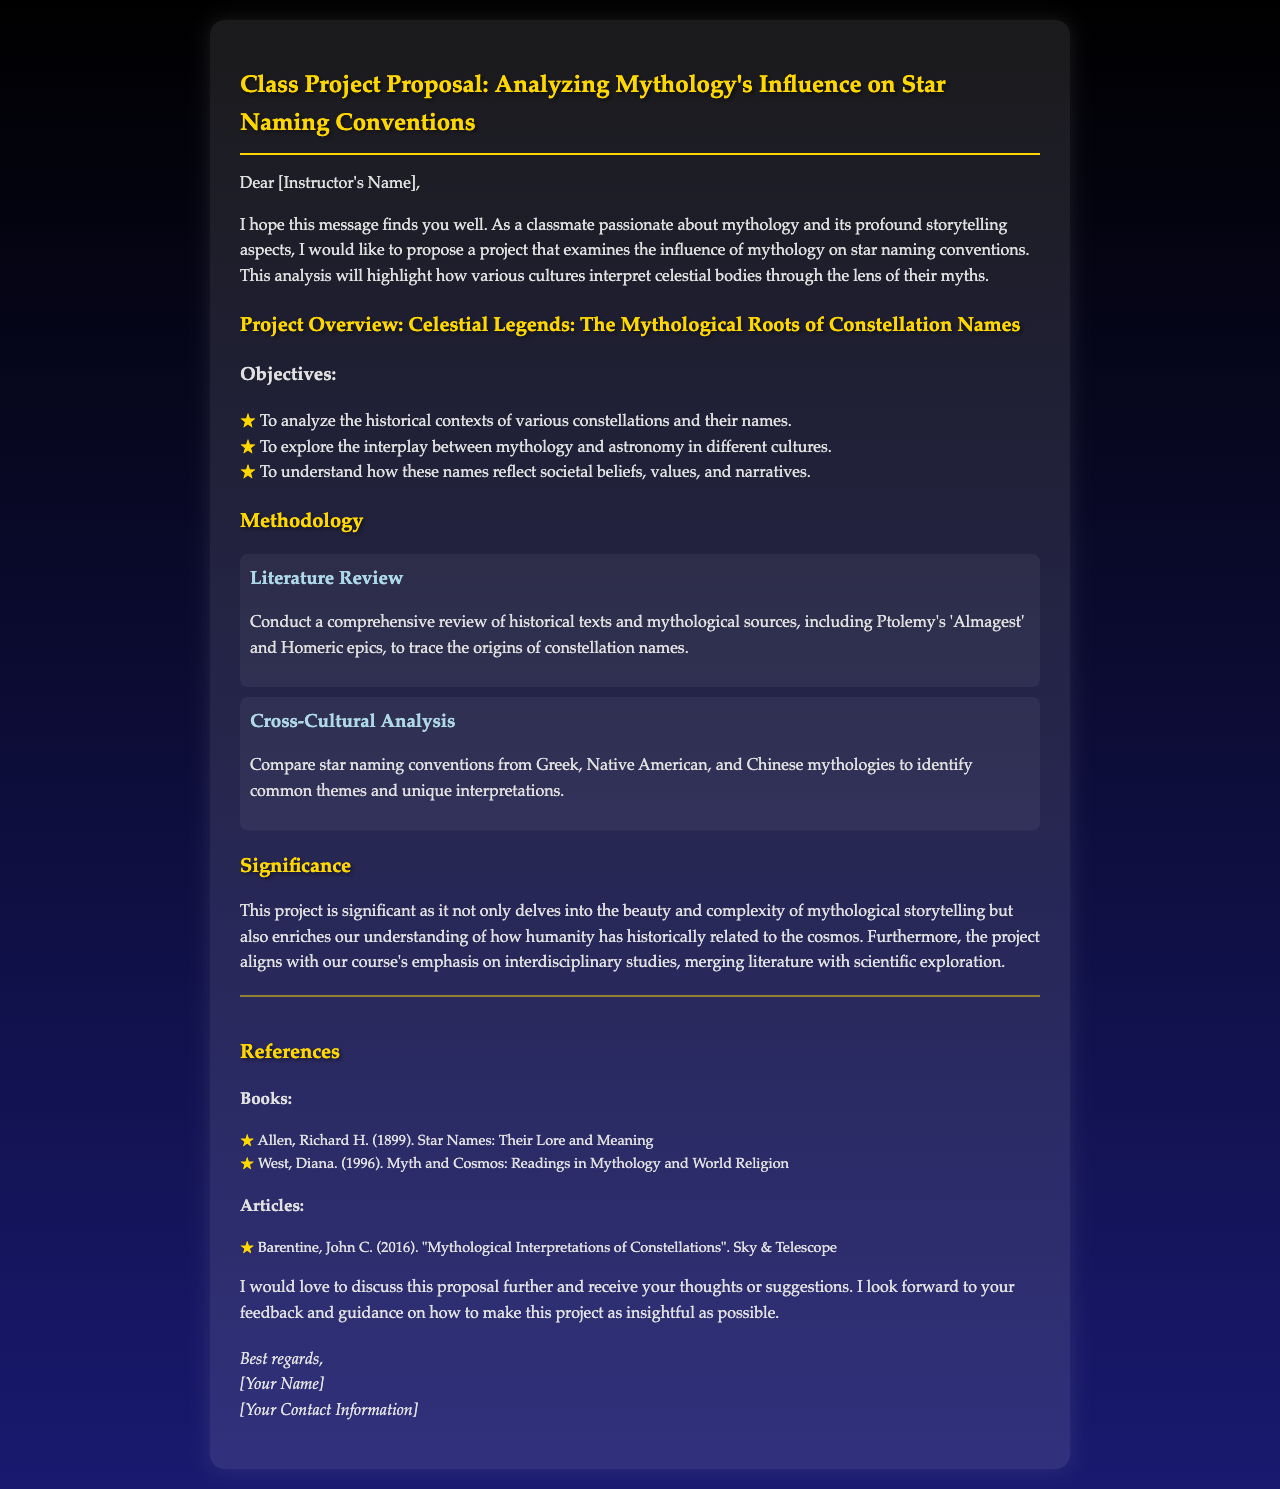What is the title of the project proposal? The title of the project proposal is stated in the heading of the email.
Answer: Class Project Proposal: Analyzing Mythology's Influence on Star Naming Conventions Who is the primary author of the proposal? The primary author is identified in the closing of the email.
Answer: [Your Name] What is one of the objectives of the project? The objectives are listed in bullet points within the document.
Answer: To analyze the historical contexts of various constellations and their names Which two mythological cultures are compared in the analysis? The methodology section mentions the cultures to be compared.
Answer: Greek and Native American What is one historical source referenced in the proposal? The literature review section lists sources that contribute to the research.
Answer: Ptolemy's 'Almagest' What is the significance of the project? The significance is summarized in a paragraph detailing its importance.
Answer: It delves into the beauty and complexity of mythological storytelling What type of document is this? The document is a formal correspondence proposing a project.
Answer: A project proposal How many references are listed in the document? The total number of references can be calculated from the sections provided.
Answer: Three references 